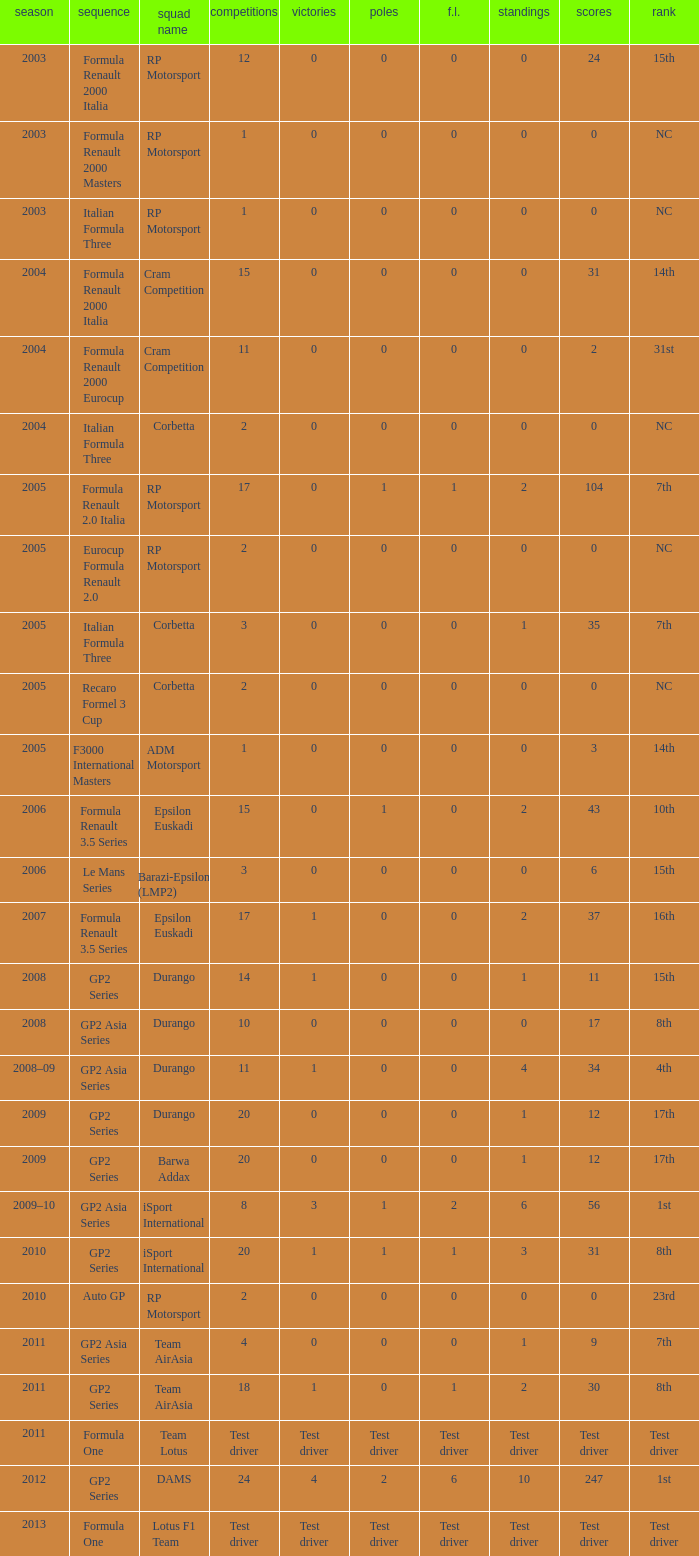What is the number of wins with a 0 F.L., 0 poles, a position of 7th, and 35 points? 0.0. 